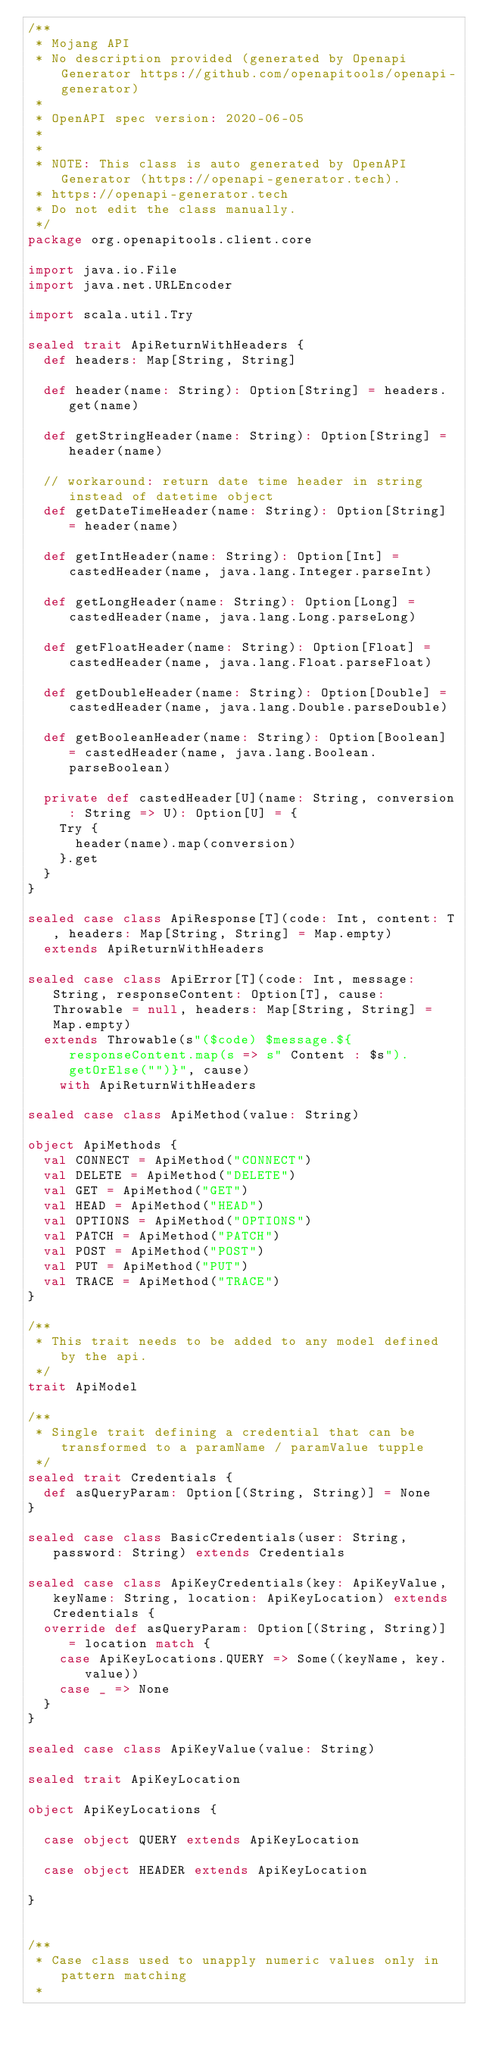Convert code to text. <code><loc_0><loc_0><loc_500><loc_500><_Scala_>/**
 * Mojang API
 * No description provided (generated by Openapi Generator https://github.com/openapitools/openapi-generator)
 *
 * OpenAPI spec version: 2020-06-05
 * 
 *
 * NOTE: This class is auto generated by OpenAPI Generator (https://openapi-generator.tech).
 * https://openapi-generator.tech
 * Do not edit the class manually.
 */
package org.openapitools.client.core

import java.io.File
import java.net.URLEncoder

import scala.util.Try

sealed trait ApiReturnWithHeaders {
  def headers: Map[String, String]

  def header(name: String): Option[String] = headers.get(name)

  def getStringHeader(name: String): Option[String] = header(name)

  // workaround: return date time header in string instead of datetime object
  def getDateTimeHeader(name: String): Option[String] = header(name)

  def getIntHeader(name: String): Option[Int] = castedHeader(name, java.lang.Integer.parseInt)

  def getLongHeader(name: String): Option[Long] = castedHeader(name, java.lang.Long.parseLong)

  def getFloatHeader(name: String): Option[Float] = castedHeader(name, java.lang.Float.parseFloat)

  def getDoubleHeader(name: String): Option[Double] = castedHeader(name, java.lang.Double.parseDouble)

  def getBooleanHeader(name: String): Option[Boolean] = castedHeader(name, java.lang.Boolean.parseBoolean)

  private def castedHeader[U](name: String, conversion: String => U): Option[U] = {
    Try {
      header(name).map(conversion)
    }.get
  }
}

sealed case class ApiResponse[T](code: Int, content: T, headers: Map[String, String] = Map.empty)
  extends ApiReturnWithHeaders

sealed case class ApiError[T](code: Int, message: String, responseContent: Option[T], cause: Throwable = null, headers: Map[String, String] = Map.empty)
  extends Throwable(s"($code) $message.${responseContent.map(s => s" Content : $s").getOrElse("")}", cause)
    with ApiReturnWithHeaders

sealed case class ApiMethod(value: String)

object ApiMethods {
  val CONNECT = ApiMethod("CONNECT")
  val DELETE = ApiMethod("DELETE")
  val GET = ApiMethod("GET")
  val HEAD = ApiMethod("HEAD")
  val OPTIONS = ApiMethod("OPTIONS")
  val PATCH = ApiMethod("PATCH")
  val POST = ApiMethod("POST")
  val PUT = ApiMethod("PUT")
  val TRACE = ApiMethod("TRACE")
}

/**
 * This trait needs to be added to any model defined by the api.
 */
trait ApiModel

/**
 * Single trait defining a credential that can be transformed to a paramName / paramValue tupple
 */
sealed trait Credentials {
  def asQueryParam: Option[(String, String)] = None
}

sealed case class BasicCredentials(user: String, password: String) extends Credentials

sealed case class ApiKeyCredentials(key: ApiKeyValue, keyName: String, location: ApiKeyLocation) extends Credentials {
  override def asQueryParam: Option[(String, String)] = location match {
    case ApiKeyLocations.QUERY => Some((keyName, key.value))
    case _ => None
  }
}

sealed case class ApiKeyValue(value: String)

sealed trait ApiKeyLocation

object ApiKeyLocations {

  case object QUERY extends ApiKeyLocation

  case object HEADER extends ApiKeyLocation

}


/**
 * Case class used to unapply numeric values only in pattern matching
 *</code> 